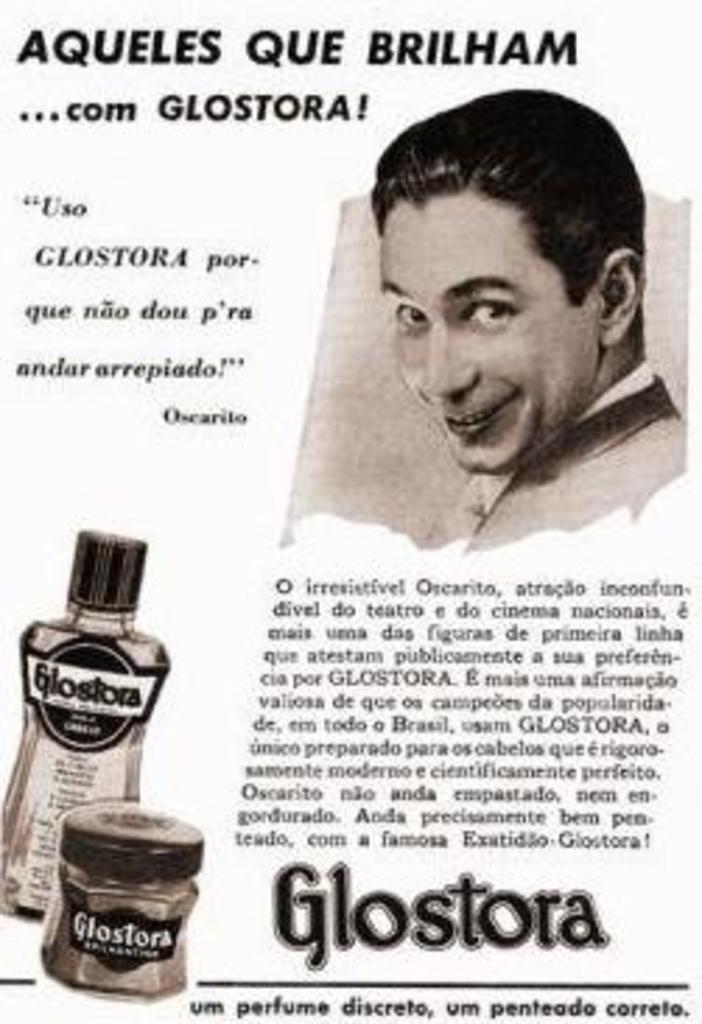What kind of product is being advertised?
Offer a very short reply. Glostora. What brand is this product?
Your answer should be compact. Glostora. 